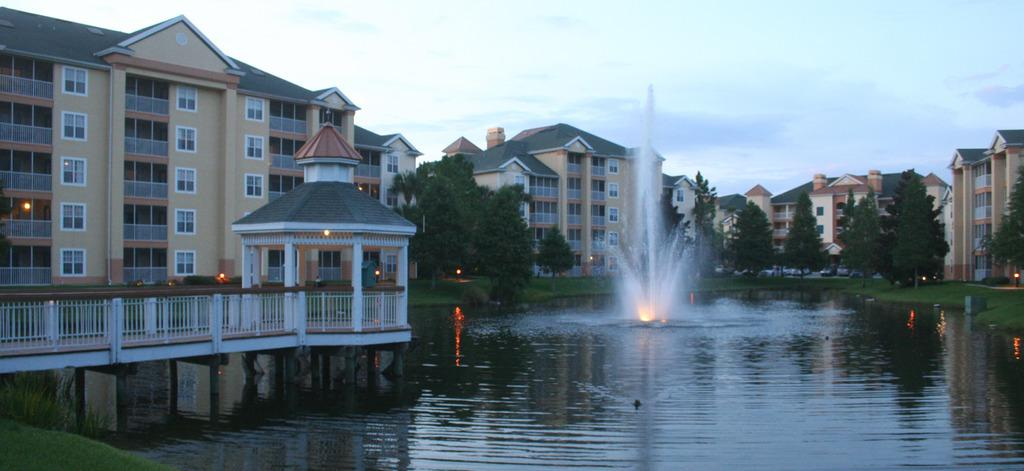What is the primary element visible in the image? There is water in the image. What type of structures can be seen in the image? There are buildings in the image. What can be used to illuminate the scene in the image? There are lights in the image. What type of vegetation is present in the image? There are trees and grass in the image. What is visible in the sky in the image? There are clouds in the image. What type of reaction can be seen from the lake in the image? There is no lake present in the image, so it is not possible to observe any reaction from a lake. Can you describe the swing in the image? There is no swing present in the image. 